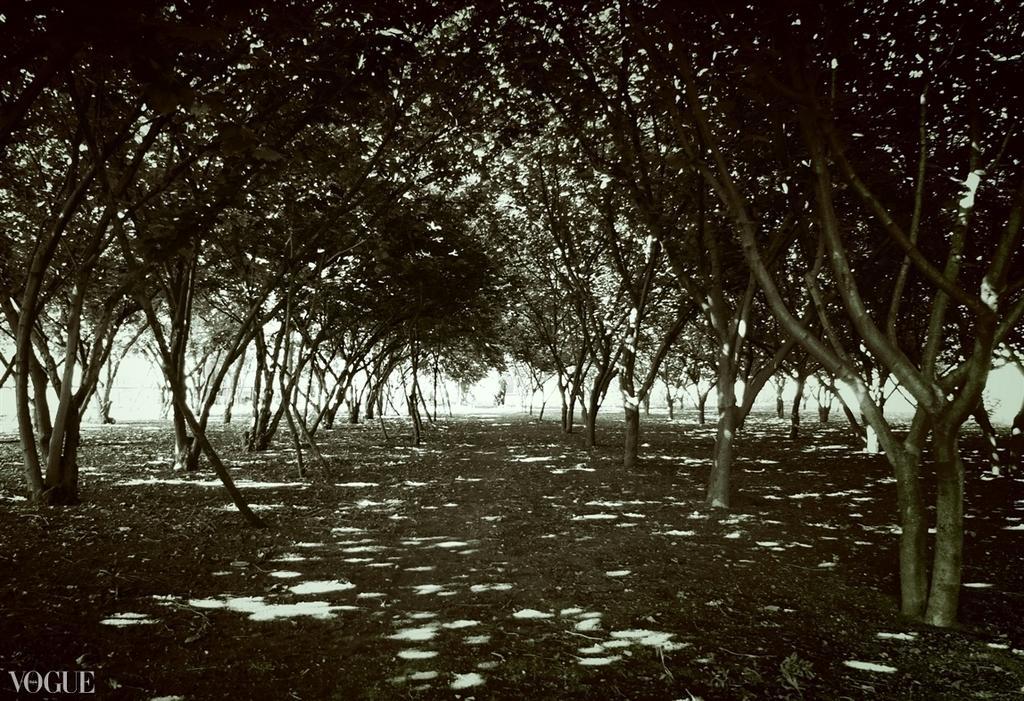Describe this image in one or two sentences. In this image we can see there are some trees and leaves on the ground. 